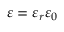<formula> <loc_0><loc_0><loc_500><loc_500>\varepsilon = \varepsilon _ { r } \varepsilon _ { 0 }</formula> 